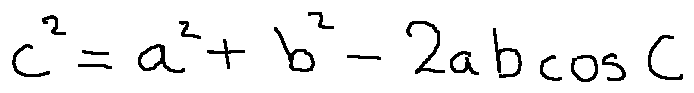<formula> <loc_0><loc_0><loc_500><loc_500>c ^ { 2 } = a ^ { 2 } + b ^ { 2 } - 2 a b \cos C</formula> 